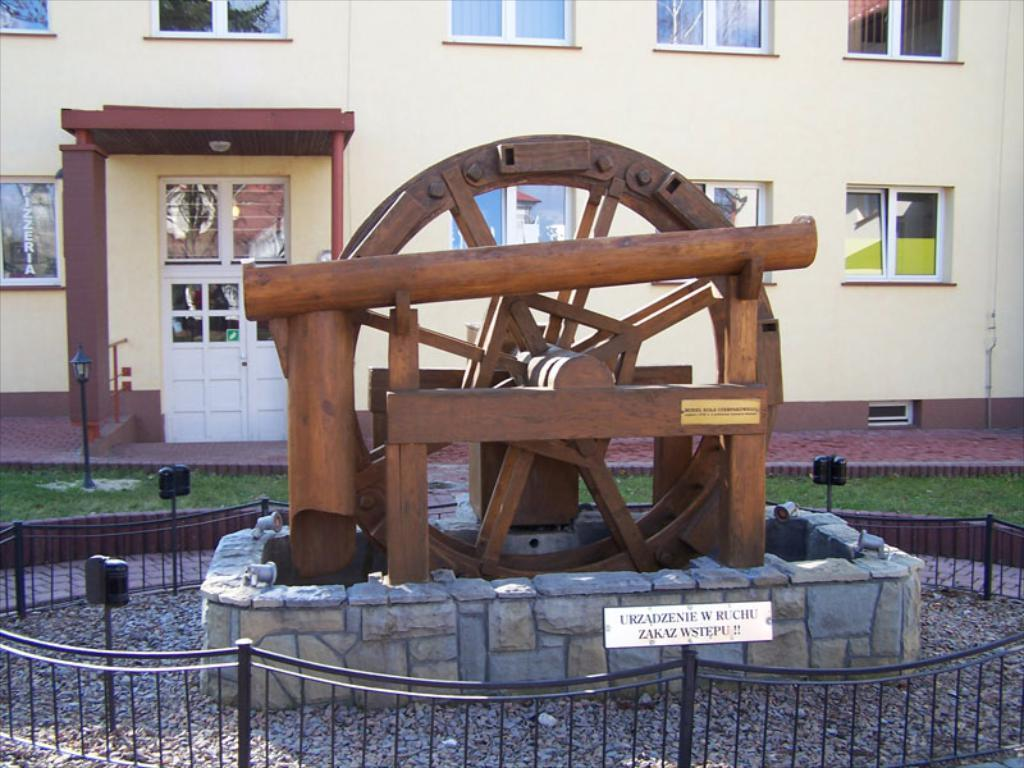What type of object is the main subject in the image? There is a wooden wheel in the image. What can be seen inside the barricade in the image? There are stones inside a barricade in the image. What is visible in the background of the image? There is a building with windows and a street lamp in the background of the image. How does the plane fly over the wooden wheel in the image? There is no plane present in the image, so it cannot fly over the wooden wheel. 